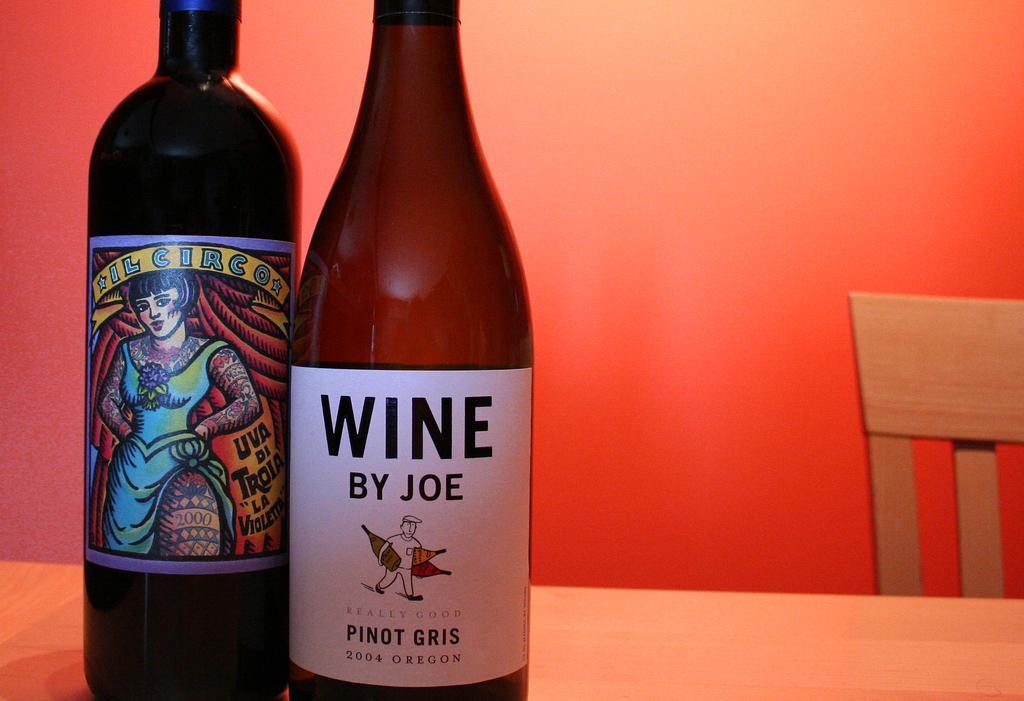<image>
Share a concise interpretation of the image provided. A bottle of Wine by Joe is on a table next to a bottle of il circo. 